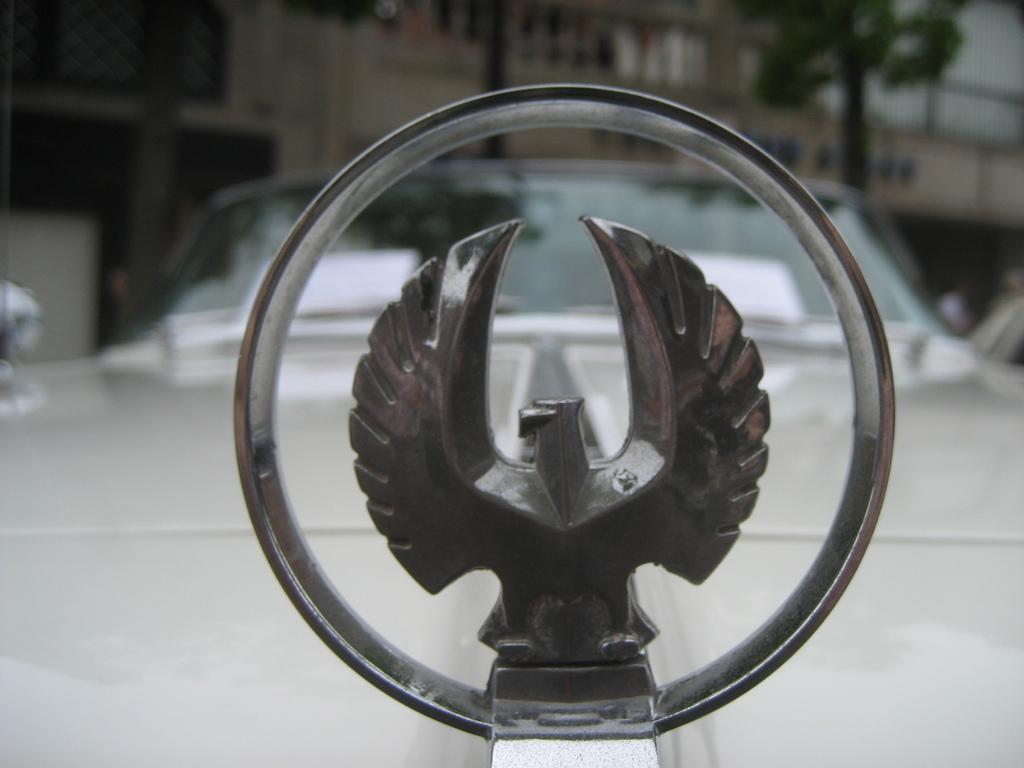How would you summarize this image in a sentence or two? In the foreground of the picture I can see the stainless steel design eagle logo and a car. In the background, I can see the building and trees. 